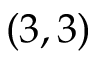Convert formula to latex. <formula><loc_0><loc_0><loc_500><loc_500>( 3 , 3 )</formula> 